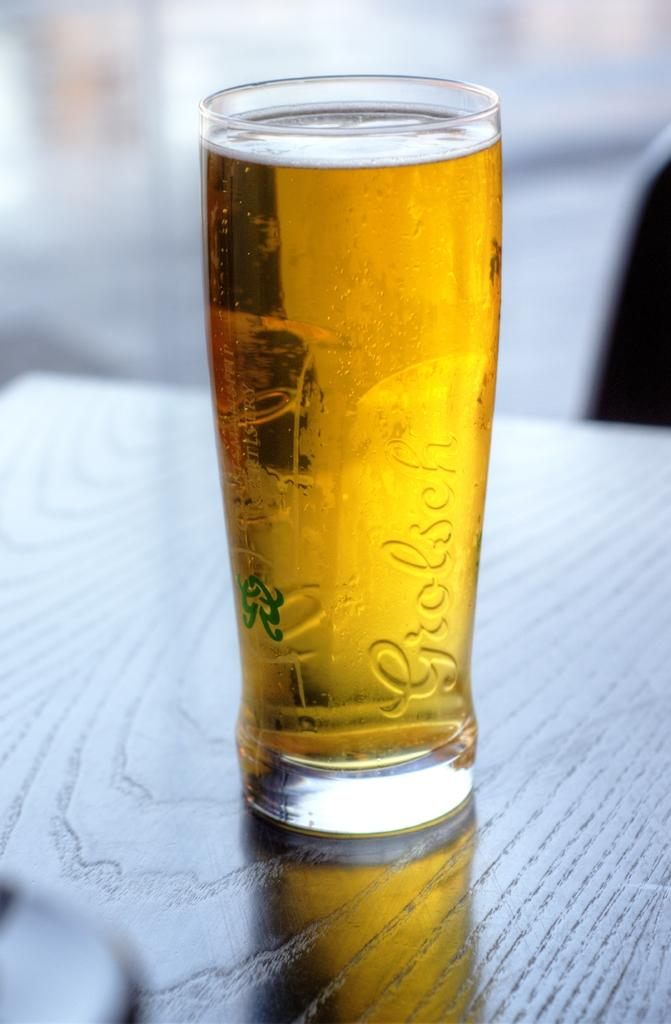Provide a one-sentence caption for the provided image. a full glass of beer with the brand grolesch on its side. 